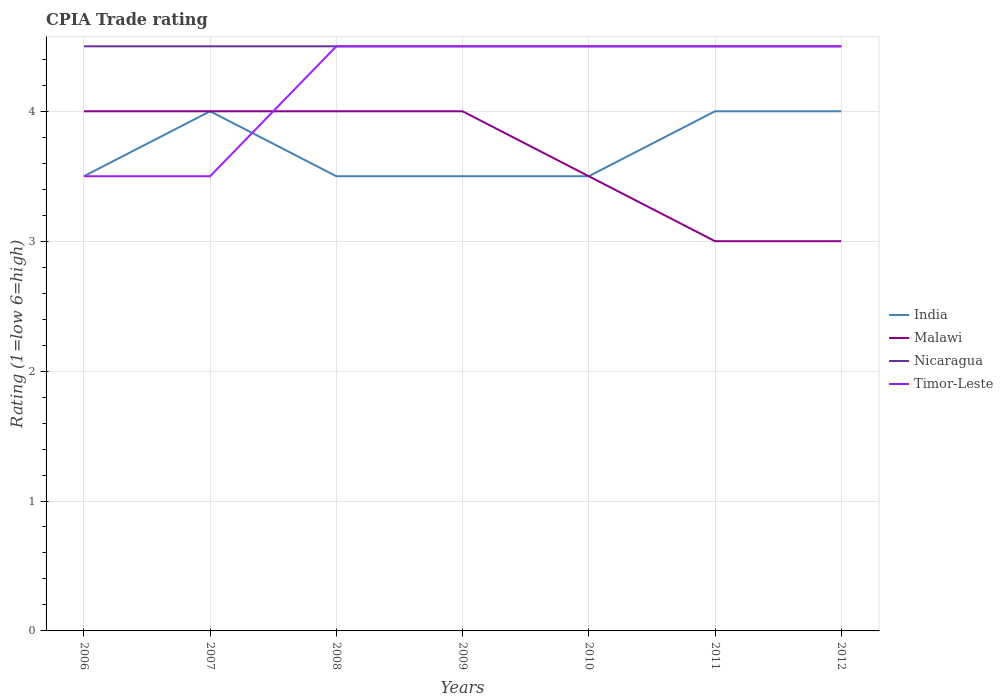How many different coloured lines are there?
Your response must be concise. 4. Is the number of lines equal to the number of legend labels?
Provide a succinct answer. Yes. Across all years, what is the maximum CPIA rating in Nicaragua?
Your answer should be compact. 4.5. What is the total CPIA rating in India in the graph?
Ensure brevity in your answer.  0.5. What is the difference between the highest and the lowest CPIA rating in India?
Offer a terse response. 3. How many lines are there?
Give a very brief answer. 4. Are the values on the major ticks of Y-axis written in scientific E-notation?
Keep it short and to the point. No. Does the graph contain any zero values?
Your response must be concise. No. How many legend labels are there?
Provide a short and direct response. 4. What is the title of the graph?
Offer a terse response. CPIA Trade rating. Does "Antigua and Barbuda" appear as one of the legend labels in the graph?
Provide a succinct answer. No. What is the label or title of the X-axis?
Your response must be concise. Years. What is the label or title of the Y-axis?
Keep it short and to the point. Rating (1=low 6=high). What is the Rating (1=low 6=high) in Nicaragua in 2006?
Give a very brief answer. 4.5. What is the Rating (1=low 6=high) in Timor-Leste in 2006?
Your response must be concise. 3.5. What is the Rating (1=low 6=high) in India in 2007?
Offer a very short reply. 4. What is the Rating (1=low 6=high) in Nicaragua in 2007?
Make the answer very short. 4.5. What is the Rating (1=low 6=high) of Timor-Leste in 2007?
Your response must be concise. 3.5. What is the Rating (1=low 6=high) of India in 2008?
Provide a succinct answer. 3.5. What is the Rating (1=low 6=high) of Malawi in 2008?
Your answer should be very brief. 4. What is the Rating (1=low 6=high) in India in 2009?
Your answer should be compact. 3.5. What is the Rating (1=low 6=high) in Timor-Leste in 2009?
Ensure brevity in your answer.  4.5. What is the Rating (1=low 6=high) in India in 2010?
Provide a succinct answer. 3.5. What is the Rating (1=low 6=high) of Malawi in 2010?
Keep it short and to the point. 3.5. What is the Rating (1=low 6=high) in Nicaragua in 2010?
Keep it short and to the point. 4.5. What is the Rating (1=low 6=high) of Timor-Leste in 2010?
Keep it short and to the point. 4.5. What is the Rating (1=low 6=high) of India in 2011?
Your response must be concise. 4. What is the Rating (1=low 6=high) in Malawi in 2011?
Your answer should be very brief. 3. What is the Rating (1=low 6=high) in India in 2012?
Keep it short and to the point. 4. Across all years, what is the maximum Rating (1=low 6=high) in Malawi?
Your answer should be compact. 4. Across all years, what is the maximum Rating (1=low 6=high) in Nicaragua?
Provide a succinct answer. 4.5. Across all years, what is the minimum Rating (1=low 6=high) of India?
Your response must be concise. 3.5. Across all years, what is the minimum Rating (1=low 6=high) of Malawi?
Provide a short and direct response. 3. Across all years, what is the minimum Rating (1=low 6=high) of Timor-Leste?
Offer a very short reply. 3.5. What is the total Rating (1=low 6=high) of Nicaragua in the graph?
Make the answer very short. 31.5. What is the total Rating (1=low 6=high) in Timor-Leste in the graph?
Provide a succinct answer. 29.5. What is the difference between the Rating (1=low 6=high) of Malawi in 2006 and that in 2007?
Offer a terse response. 0. What is the difference between the Rating (1=low 6=high) of Nicaragua in 2006 and that in 2007?
Make the answer very short. 0. What is the difference between the Rating (1=low 6=high) in India in 2006 and that in 2008?
Give a very brief answer. 0. What is the difference between the Rating (1=low 6=high) in Malawi in 2006 and that in 2008?
Your response must be concise. 0. What is the difference between the Rating (1=low 6=high) of Nicaragua in 2006 and that in 2008?
Ensure brevity in your answer.  0. What is the difference between the Rating (1=low 6=high) of Malawi in 2006 and that in 2009?
Your answer should be very brief. 0. What is the difference between the Rating (1=low 6=high) of Malawi in 2006 and that in 2010?
Offer a very short reply. 0.5. What is the difference between the Rating (1=low 6=high) in India in 2006 and that in 2011?
Your response must be concise. -0.5. What is the difference between the Rating (1=low 6=high) of India in 2006 and that in 2012?
Keep it short and to the point. -0.5. What is the difference between the Rating (1=low 6=high) in Malawi in 2006 and that in 2012?
Offer a terse response. 1. What is the difference between the Rating (1=low 6=high) of Nicaragua in 2006 and that in 2012?
Offer a terse response. 0. What is the difference between the Rating (1=low 6=high) in Malawi in 2007 and that in 2008?
Your response must be concise. 0. What is the difference between the Rating (1=low 6=high) in Timor-Leste in 2007 and that in 2008?
Make the answer very short. -1. What is the difference between the Rating (1=low 6=high) in Nicaragua in 2007 and that in 2010?
Provide a short and direct response. 0. What is the difference between the Rating (1=low 6=high) in India in 2007 and that in 2011?
Give a very brief answer. 0. What is the difference between the Rating (1=low 6=high) in Nicaragua in 2007 and that in 2011?
Offer a terse response. 0. What is the difference between the Rating (1=low 6=high) in India in 2007 and that in 2012?
Provide a short and direct response. 0. What is the difference between the Rating (1=low 6=high) in Malawi in 2007 and that in 2012?
Give a very brief answer. 1. What is the difference between the Rating (1=low 6=high) of India in 2008 and that in 2009?
Your answer should be compact. 0. What is the difference between the Rating (1=low 6=high) of Malawi in 2008 and that in 2009?
Provide a short and direct response. 0. What is the difference between the Rating (1=low 6=high) of Nicaragua in 2008 and that in 2009?
Offer a terse response. 0. What is the difference between the Rating (1=low 6=high) of Timor-Leste in 2008 and that in 2009?
Give a very brief answer. 0. What is the difference between the Rating (1=low 6=high) of Nicaragua in 2008 and that in 2010?
Provide a short and direct response. 0. What is the difference between the Rating (1=low 6=high) of Timor-Leste in 2008 and that in 2010?
Offer a terse response. 0. What is the difference between the Rating (1=low 6=high) in Malawi in 2008 and that in 2011?
Provide a succinct answer. 1. What is the difference between the Rating (1=low 6=high) of Nicaragua in 2008 and that in 2011?
Your response must be concise. 0. What is the difference between the Rating (1=low 6=high) in Timor-Leste in 2008 and that in 2011?
Keep it short and to the point. 0. What is the difference between the Rating (1=low 6=high) in Malawi in 2008 and that in 2012?
Provide a succinct answer. 1. What is the difference between the Rating (1=low 6=high) in India in 2009 and that in 2010?
Provide a short and direct response. 0. What is the difference between the Rating (1=low 6=high) of Malawi in 2009 and that in 2010?
Your answer should be very brief. 0.5. What is the difference between the Rating (1=low 6=high) in Nicaragua in 2009 and that in 2010?
Your response must be concise. 0. What is the difference between the Rating (1=low 6=high) in Malawi in 2009 and that in 2011?
Ensure brevity in your answer.  1. What is the difference between the Rating (1=low 6=high) of Nicaragua in 2009 and that in 2011?
Offer a very short reply. 0. What is the difference between the Rating (1=low 6=high) in India in 2010 and that in 2011?
Provide a succinct answer. -0.5. What is the difference between the Rating (1=low 6=high) in Nicaragua in 2010 and that in 2011?
Make the answer very short. 0. What is the difference between the Rating (1=low 6=high) of Timor-Leste in 2010 and that in 2011?
Offer a terse response. 0. What is the difference between the Rating (1=low 6=high) of India in 2010 and that in 2012?
Make the answer very short. -0.5. What is the difference between the Rating (1=low 6=high) in Timor-Leste in 2011 and that in 2012?
Your response must be concise. 0. What is the difference between the Rating (1=low 6=high) of India in 2006 and the Rating (1=low 6=high) of Nicaragua in 2007?
Provide a short and direct response. -1. What is the difference between the Rating (1=low 6=high) in Malawi in 2006 and the Rating (1=low 6=high) in Nicaragua in 2007?
Your response must be concise. -0.5. What is the difference between the Rating (1=low 6=high) in Nicaragua in 2006 and the Rating (1=low 6=high) in Timor-Leste in 2007?
Your response must be concise. 1. What is the difference between the Rating (1=low 6=high) of India in 2006 and the Rating (1=low 6=high) of Malawi in 2008?
Your answer should be very brief. -0.5. What is the difference between the Rating (1=low 6=high) in Malawi in 2006 and the Rating (1=low 6=high) in Nicaragua in 2008?
Offer a very short reply. -0.5. What is the difference between the Rating (1=low 6=high) in India in 2006 and the Rating (1=low 6=high) in Nicaragua in 2009?
Ensure brevity in your answer.  -1. What is the difference between the Rating (1=low 6=high) in India in 2006 and the Rating (1=low 6=high) in Timor-Leste in 2009?
Make the answer very short. -1. What is the difference between the Rating (1=low 6=high) of Malawi in 2006 and the Rating (1=low 6=high) of Nicaragua in 2009?
Your answer should be very brief. -0.5. What is the difference between the Rating (1=low 6=high) in Malawi in 2006 and the Rating (1=low 6=high) in Timor-Leste in 2009?
Provide a succinct answer. -0.5. What is the difference between the Rating (1=low 6=high) in India in 2006 and the Rating (1=low 6=high) in Timor-Leste in 2010?
Your answer should be compact. -1. What is the difference between the Rating (1=low 6=high) of India in 2006 and the Rating (1=low 6=high) of Malawi in 2011?
Provide a succinct answer. 0.5. What is the difference between the Rating (1=low 6=high) in India in 2006 and the Rating (1=low 6=high) in Nicaragua in 2011?
Give a very brief answer. -1. What is the difference between the Rating (1=low 6=high) of India in 2006 and the Rating (1=low 6=high) of Timor-Leste in 2011?
Provide a succinct answer. -1. What is the difference between the Rating (1=low 6=high) in Malawi in 2006 and the Rating (1=low 6=high) in Nicaragua in 2011?
Make the answer very short. -0.5. What is the difference between the Rating (1=low 6=high) of Malawi in 2006 and the Rating (1=low 6=high) of Timor-Leste in 2011?
Provide a short and direct response. -0.5. What is the difference between the Rating (1=low 6=high) of India in 2006 and the Rating (1=low 6=high) of Malawi in 2012?
Your answer should be very brief. 0.5. What is the difference between the Rating (1=low 6=high) in Malawi in 2006 and the Rating (1=low 6=high) in Nicaragua in 2012?
Give a very brief answer. -0.5. What is the difference between the Rating (1=low 6=high) in Malawi in 2006 and the Rating (1=low 6=high) in Timor-Leste in 2012?
Ensure brevity in your answer.  -0.5. What is the difference between the Rating (1=low 6=high) in Nicaragua in 2006 and the Rating (1=low 6=high) in Timor-Leste in 2012?
Give a very brief answer. 0. What is the difference between the Rating (1=low 6=high) in India in 2007 and the Rating (1=low 6=high) in Malawi in 2008?
Give a very brief answer. 0. What is the difference between the Rating (1=low 6=high) in Malawi in 2007 and the Rating (1=low 6=high) in Nicaragua in 2008?
Keep it short and to the point. -0.5. What is the difference between the Rating (1=low 6=high) in Nicaragua in 2007 and the Rating (1=low 6=high) in Timor-Leste in 2008?
Make the answer very short. 0. What is the difference between the Rating (1=low 6=high) of India in 2007 and the Rating (1=low 6=high) of Timor-Leste in 2009?
Make the answer very short. -0.5. What is the difference between the Rating (1=low 6=high) of Malawi in 2007 and the Rating (1=low 6=high) of Nicaragua in 2009?
Provide a short and direct response. -0.5. What is the difference between the Rating (1=low 6=high) of Malawi in 2007 and the Rating (1=low 6=high) of Timor-Leste in 2009?
Ensure brevity in your answer.  -0.5. What is the difference between the Rating (1=low 6=high) in Malawi in 2007 and the Rating (1=low 6=high) in Nicaragua in 2010?
Make the answer very short. -0.5. What is the difference between the Rating (1=low 6=high) in Malawi in 2007 and the Rating (1=low 6=high) in Timor-Leste in 2010?
Your response must be concise. -0.5. What is the difference between the Rating (1=low 6=high) in Nicaragua in 2007 and the Rating (1=low 6=high) in Timor-Leste in 2010?
Your response must be concise. 0. What is the difference between the Rating (1=low 6=high) of Malawi in 2007 and the Rating (1=low 6=high) of Nicaragua in 2011?
Ensure brevity in your answer.  -0.5. What is the difference between the Rating (1=low 6=high) in India in 2007 and the Rating (1=low 6=high) in Malawi in 2012?
Ensure brevity in your answer.  1. What is the difference between the Rating (1=low 6=high) in India in 2007 and the Rating (1=low 6=high) in Nicaragua in 2012?
Offer a very short reply. -0.5. What is the difference between the Rating (1=low 6=high) in India in 2007 and the Rating (1=low 6=high) in Timor-Leste in 2012?
Ensure brevity in your answer.  -0.5. What is the difference between the Rating (1=low 6=high) of Nicaragua in 2007 and the Rating (1=low 6=high) of Timor-Leste in 2012?
Your answer should be very brief. 0. What is the difference between the Rating (1=low 6=high) of India in 2008 and the Rating (1=low 6=high) of Malawi in 2009?
Your answer should be very brief. -0.5. What is the difference between the Rating (1=low 6=high) in India in 2008 and the Rating (1=low 6=high) in Nicaragua in 2009?
Provide a succinct answer. -1. What is the difference between the Rating (1=low 6=high) in India in 2008 and the Rating (1=low 6=high) in Timor-Leste in 2009?
Your response must be concise. -1. What is the difference between the Rating (1=low 6=high) of Malawi in 2008 and the Rating (1=low 6=high) of Timor-Leste in 2009?
Provide a succinct answer. -0.5. What is the difference between the Rating (1=low 6=high) of Nicaragua in 2008 and the Rating (1=low 6=high) of Timor-Leste in 2009?
Keep it short and to the point. 0. What is the difference between the Rating (1=low 6=high) of India in 2008 and the Rating (1=low 6=high) of Malawi in 2010?
Provide a succinct answer. 0. What is the difference between the Rating (1=low 6=high) in India in 2008 and the Rating (1=low 6=high) in Nicaragua in 2010?
Offer a very short reply. -1. What is the difference between the Rating (1=low 6=high) of Nicaragua in 2008 and the Rating (1=low 6=high) of Timor-Leste in 2010?
Your response must be concise. 0. What is the difference between the Rating (1=low 6=high) in India in 2008 and the Rating (1=low 6=high) in Malawi in 2011?
Provide a succinct answer. 0.5. What is the difference between the Rating (1=low 6=high) in India in 2008 and the Rating (1=low 6=high) in Timor-Leste in 2011?
Keep it short and to the point. -1. What is the difference between the Rating (1=low 6=high) in Malawi in 2008 and the Rating (1=low 6=high) in Timor-Leste in 2011?
Ensure brevity in your answer.  -0.5. What is the difference between the Rating (1=low 6=high) in Nicaragua in 2008 and the Rating (1=low 6=high) in Timor-Leste in 2011?
Ensure brevity in your answer.  0. What is the difference between the Rating (1=low 6=high) of India in 2008 and the Rating (1=low 6=high) of Malawi in 2012?
Provide a succinct answer. 0.5. What is the difference between the Rating (1=low 6=high) in India in 2008 and the Rating (1=low 6=high) in Nicaragua in 2012?
Provide a short and direct response. -1. What is the difference between the Rating (1=low 6=high) in Malawi in 2008 and the Rating (1=low 6=high) in Nicaragua in 2012?
Provide a short and direct response. -0.5. What is the difference between the Rating (1=low 6=high) in India in 2009 and the Rating (1=low 6=high) in Nicaragua in 2010?
Give a very brief answer. -1. What is the difference between the Rating (1=low 6=high) in Malawi in 2009 and the Rating (1=low 6=high) in Nicaragua in 2010?
Ensure brevity in your answer.  -0.5. What is the difference between the Rating (1=low 6=high) in Nicaragua in 2009 and the Rating (1=low 6=high) in Timor-Leste in 2010?
Your response must be concise. 0. What is the difference between the Rating (1=low 6=high) of India in 2009 and the Rating (1=low 6=high) of Timor-Leste in 2011?
Your answer should be very brief. -1. What is the difference between the Rating (1=low 6=high) of Malawi in 2009 and the Rating (1=low 6=high) of Nicaragua in 2011?
Offer a very short reply. -0.5. What is the difference between the Rating (1=low 6=high) of Malawi in 2009 and the Rating (1=low 6=high) of Timor-Leste in 2011?
Keep it short and to the point. -0.5. What is the difference between the Rating (1=low 6=high) in India in 2009 and the Rating (1=low 6=high) in Malawi in 2012?
Provide a succinct answer. 0.5. What is the difference between the Rating (1=low 6=high) of Malawi in 2009 and the Rating (1=low 6=high) of Nicaragua in 2012?
Your answer should be very brief. -0.5. What is the difference between the Rating (1=low 6=high) in Malawi in 2009 and the Rating (1=low 6=high) in Timor-Leste in 2012?
Offer a very short reply. -0.5. What is the difference between the Rating (1=low 6=high) of India in 2010 and the Rating (1=low 6=high) of Malawi in 2011?
Offer a terse response. 0.5. What is the difference between the Rating (1=low 6=high) in India in 2010 and the Rating (1=low 6=high) in Nicaragua in 2011?
Your answer should be compact. -1. What is the difference between the Rating (1=low 6=high) of India in 2010 and the Rating (1=low 6=high) of Timor-Leste in 2011?
Ensure brevity in your answer.  -1. What is the difference between the Rating (1=low 6=high) in Malawi in 2010 and the Rating (1=low 6=high) in Timor-Leste in 2011?
Offer a very short reply. -1. What is the difference between the Rating (1=low 6=high) of India in 2010 and the Rating (1=low 6=high) of Malawi in 2012?
Offer a terse response. 0.5. What is the difference between the Rating (1=low 6=high) in India in 2010 and the Rating (1=low 6=high) in Nicaragua in 2012?
Provide a succinct answer. -1. What is the difference between the Rating (1=low 6=high) of India in 2010 and the Rating (1=low 6=high) of Timor-Leste in 2012?
Provide a succinct answer. -1. What is the difference between the Rating (1=low 6=high) in Malawi in 2010 and the Rating (1=low 6=high) in Nicaragua in 2012?
Make the answer very short. -1. What is the difference between the Rating (1=low 6=high) of India in 2011 and the Rating (1=low 6=high) of Malawi in 2012?
Offer a very short reply. 1. What is the difference between the Rating (1=low 6=high) in India in 2011 and the Rating (1=low 6=high) in Timor-Leste in 2012?
Make the answer very short. -0.5. What is the difference between the Rating (1=low 6=high) in Malawi in 2011 and the Rating (1=low 6=high) in Timor-Leste in 2012?
Ensure brevity in your answer.  -1.5. What is the average Rating (1=low 6=high) of India per year?
Keep it short and to the point. 3.71. What is the average Rating (1=low 6=high) of Malawi per year?
Make the answer very short. 3.64. What is the average Rating (1=low 6=high) in Nicaragua per year?
Make the answer very short. 4.5. What is the average Rating (1=low 6=high) of Timor-Leste per year?
Keep it short and to the point. 4.21. In the year 2006, what is the difference between the Rating (1=low 6=high) of India and Rating (1=low 6=high) of Timor-Leste?
Provide a succinct answer. 0. In the year 2006, what is the difference between the Rating (1=low 6=high) in Malawi and Rating (1=low 6=high) in Nicaragua?
Keep it short and to the point. -0.5. In the year 2006, what is the difference between the Rating (1=low 6=high) in Malawi and Rating (1=low 6=high) in Timor-Leste?
Give a very brief answer. 0.5. In the year 2006, what is the difference between the Rating (1=low 6=high) in Nicaragua and Rating (1=low 6=high) in Timor-Leste?
Ensure brevity in your answer.  1. In the year 2007, what is the difference between the Rating (1=low 6=high) in India and Rating (1=low 6=high) in Nicaragua?
Offer a very short reply. -0.5. In the year 2007, what is the difference between the Rating (1=low 6=high) in Malawi and Rating (1=low 6=high) in Nicaragua?
Keep it short and to the point. -0.5. In the year 2008, what is the difference between the Rating (1=low 6=high) of India and Rating (1=low 6=high) of Malawi?
Offer a very short reply. -0.5. In the year 2008, what is the difference between the Rating (1=low 6=high) of India and Rating (1=low 6=high) of Nicaragua?
Give a very brief answer. -1. In the year 2008, what is the difference between the Rating (1=low 6=high) in Malawi and Rating (1=low 6=high) in Nicaragua?
Your answer should be very brief. -0.5. In the year 2009, what is the difference between the Rating (1=low 6=high) of India and Rating (1=low 6=high) of Malawi?
Keep it short and to the point. -0.5. In the year 2009, what is the difference between the Rating (1=low 6=high) in India and Rating (1=low 6=high) in Nicaragua?
Offer a terse response. -1. In the year 2009, what is the difference between the Rating (1=low 6=high) in Malawi and Rating (1=low 6=high) in Timor-Leste?
Your answer should be compact. -0.5. In the year 2010, what is the difference between the Rating (1=low 6=high) of India and Rating (1=low 6=high) of Malawi?
Offer a terse response. 0. In the year 2010, what is the difference between the Rating (1=low 6=high) of India and Rating (1=low 6=high) of Nicaragua?
Make the answer very short. -1. In the year 2010, what is the difference between the Rating (1=low 6=high) of Malawi and Rating (1=low 6=high) of Nicaragua?
Give a very brief answer. -1. In the year 2011, what is the difference between the Rating (1=low 6=high) of India and Rating (1=low 6=high) of Nicaragua?
Provide a succinct answer. -0.5. In the year 2012, what is the difference between the Rating (1=low 6=high) of India and Rating (1=low 6=high) of Timor-Leste?
Provide a short and direct response. -0.5. In the year 2012, what is the difference between the Rating (1=low 6=high) of Nicaragua and Rating (1=low 6=high) of Timor-Leste?
Provide a short and direct response. 0. What is the ratio of the Rating (1=low 6=high) in India in 2006 to that in 2007?
Keep it short and to the point. 0.88. What is the ratio of the Rating (1=low 6=high) of Malawi in 2006 to that in 2007?
Give a very brief answer. 1. What is the ratio of the Rating (1=low 6=high) in Nicaragua in 2006 to that in 2007?
Make the answer very short. 1. What is the ratio of the Rating (1=low 6=high) in Timor-Leste in 2006 to that in 2007?
Offer a terse response. 1. What is the ratio of the Rating (1=low 6=high) of India in 2006 to that in 2008?
Your answer should be very brief. 1. What is the ratio of the Rating (1=low 6=high) in Malawi in 2006 to that in 2008?
Ensure brevity in your answer.  1. What is the ratio of the Rating (1=low 6=high) in Nicaragua in 2006 to that in 2008?
Your answer should be very brief. 1. What is the ratio of the Rating (1=low 6=high) in India in 2006 to that in 2009?
Your answer should be compact. 1. What is the ratio of the Rating (1=low 6=high) of Malawi in 2006 to that in 2009?
Provide a succinct answer. 1. What is the ratio of the Rating (1=low 6=high) in Timor-Leste in 2006 to that in 2009?
Your response must be concise. 0.78. What is the ratio of the Rating (1=low 6=high) of Malawi in 2006 to that in 2010?
Provide a short and direct response. 1.14. What is the ratio of the Rating (1=low 6=high) in India in 2006 to that in 2011?
Your answer should be very brief. 0.88. What is the ratio of the Rating (1=low 6=high) of Malawi in 2006 to that in 2011?
Keep it short and to the point. 1.33. What is the ratio of the Rating (1=low 6=high) of Malawi in 2007 to that in 2008?
Offer a terse response. 1. What is the ratio of the Rating (1=low 6=high) of India in 2007 to that in 2009?
Ensure brevity in your answer.  1.14. What is the ratio of the Rating (1=low 6=high) of Timor-Leste in 2007 to that in 2009?
Keep it short and to the point. 0.78. What is the ratio of the Rating (1=low 6=high) of India in 2007 to that in 2010?
Provide a succinct answer. 1.14. What is the ratio of the Rating (1=low 6=high) of India in 2007 to that in 2011?
Provide a succinct answer. 1. What is the ratio of the Rating (1=low 6=high) of Timor-Leste in 2007 to that in 2011?
Provide a short and direct response. 0.78. What is the ratio of the Rating (1=low 6=high) in India in 2007 to that in 2012?
Offer a very short reply. 1. What is the ratio of the Rating (1=low 6=high) in Malawi in 2007 to that in 2012?
Keep it short and to the point. 1.33. What is the ratio of the Rating (1=low 6=high) of Nicaragua in 2007 to that in 2012?
Your answer should be compact. 1. What is the ratio of the Rating (1=low 6=high) in India in 2008 to that in 2009?
Provide a succinct answer. 1. What is the ratio of the Rating (1=low 6=high) in Nicaragua in 2008 to that in 2009?
Your answer should be very brief. 1. What is the ratio of the Rating (1=low 6=high) of Nicaragua in 2008 to that in 2010?
Your response must be concise. 1. What is the ratio of the Rating (1=low 6=high) of India in 2008 to that in 2011?
Your answer should be very brief. 0.88. What is the ratio of the Rating (1=low 6=high) in Nicaragua in 2008 to that in 2011?
Provide a succinct answer. 1. What is the ratio of the Rating (1=low 6=high) of Nicaragua in 2008 to that in 2012?
Make the answer very short. 1. What is the ratio of the Rating (1=low 6=high) in India in 2009 to that in 2010?
Make the answer very short. 1. What is the ratio of the Rating (1=low 6=high) of Malawi in 2009 to that in 2010?
Your answer should be compact. 1.14. What is the ratio of the Rating (1=low 6=high) of Timor-Leste in 2009 to that in 2010?
Your answer should be very brief. 1. What is the ratio of the Rating (1=low 6=high) in India in 2009 to that in 2011?
Offer a very short reply. 0.88. What is the ratio of the Rating (1=low 6=high) in Malawi in 2009 to that in 2011?
Give a very brief answer. 1.33. What is the ratio of the Rating (1=low 6=high) in Nicaragua in 2009 to that in 2011?
Give a very brief answer. 1. What is the ratio of the Rating (1=low 6=high) in Timor-Leste in 2009 to that in 2011?
Your answer should be compact. 1. What is the ratio of the Rating (1=low 6=high) in Malawi in 2009 to that in 2012?
Your response must be concise. 1.33. What is the ratio of the Rating (1=low 6=high) in Nicaragua in 2009 to that in 2012?
Ensure brevity in your answer.  1. What is the ratio of the Rating (1=low 6=high) in Malawi in 2010 to that in 2011?
Provide a short and direct response. 1.17. What is the ratio of the Rating (1=low 6=high) in Timor-Leste in 2010 to that in 2011?
Offer a terse response. 1. What is the ratio of the Rating (1=low 6=high) in India in 2011 to that in 2012?
Keep it short and to the point. 1. What is the ratio of the Rating (1=low 6=high) of Malawi in 2011 to that in 2012?
Give a very brief answer. 1. What is the ratio of the Rating (1=low 6=high) of Nicaragua in 2011 to that in 2012?
Give a very brief answer. 1. What is the difference between the highest and the second highest Rating (1=low 6=high) of Malawi?
Provide a succinct answer. 0. What is the difference between the highest and the second highest Rating (1=low 6=high) in Nicaragua?
Provide a short and direct response. 0. What is the difference between the highest and the lowest Rating (1=low 6=high) in Nicaragua?
Make the answer very short. 0. 